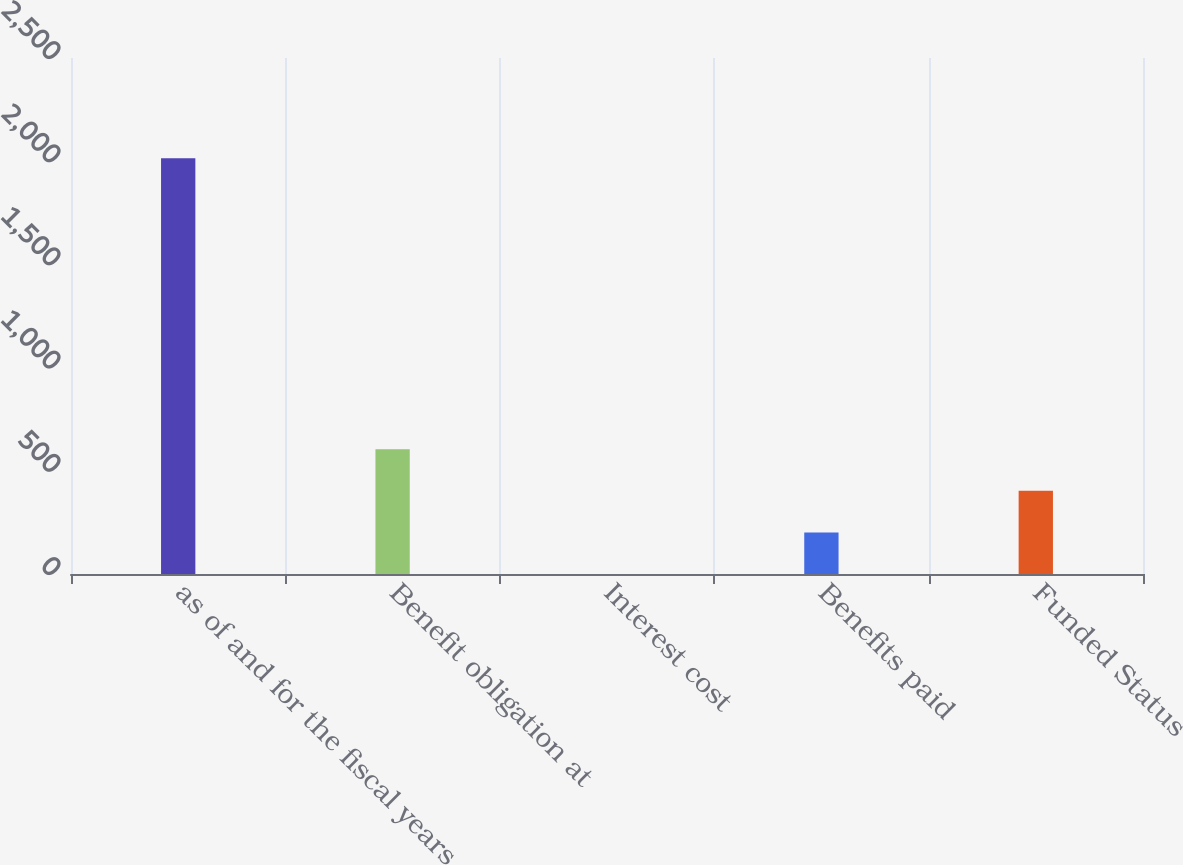Convert chart to OTSL. <chart><loc_0><loc_0><loc_500><loc_500><bar_chart><fcel>as of and for the fiscal years<fcel>Benefit obligation at<fcel>Interest cost<fcel>Benefits paid<fcel>Funded Status<nl><fcel>2014<fcel>604.34<fcel>0.2<fcel>201.58<fcel>402.96<nl></chart> 